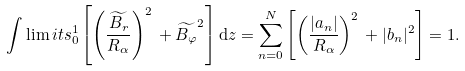Convert formula to latex. <formula><loc_0><loc_0><loc_500><loc_500>\int \lim i t s _ { 0 } ^ { 1 } \left [ \left ( \frac { \widetilde { B _ { r } } } { R _ { \alpha } } \right ) ^ { 2 } \, + \widetilde { B _ { \varphi } } ^ { 2 } \right ] \mathrm d z = \sum _ { n = 0 } ^ { N } \left [ \left ( \frac { | a _ { n } | } { R _ { \alpha } } \right ) ^ { 2 } \, + | b _ { n } | ^ { 2 } \right ] = 1 .</formula> 